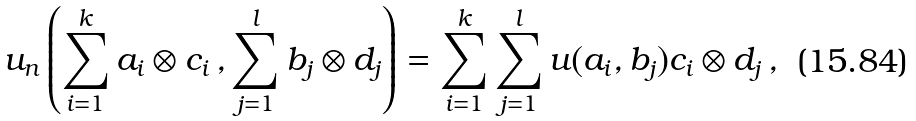Convert formula to latex. <formula><loc_0><loc_0><loc_500><loc_500>u _ { n } \left ( \sum _ { i = 1 } ^ { k } a _ { i } \otimes c _ { i } \, , \sum _ { j = 1 } ^ { l } b _ { j } \otimes d _ { j } \right ) = \sum _ { i = 1 } ^ { k } \sum _ { j = 1 } ^ { l } u ( a _ { i } , b _ { j } ) c _ { i } \otimes d _ { j } \, ,</formula> 